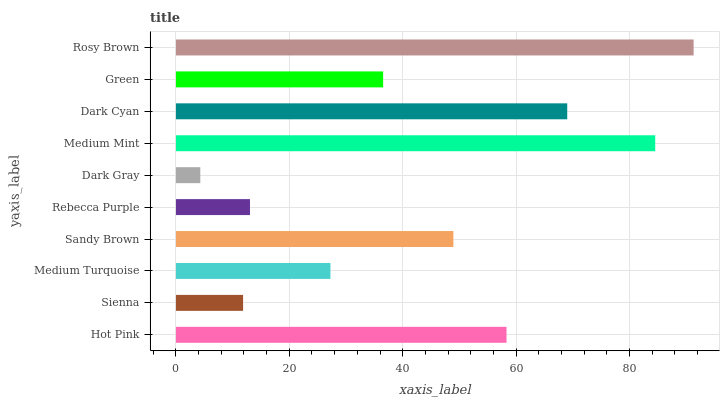Is Dark Gray the minimum?
Answer yes or no. Yes. Is Rosy Brown the maximum?
Answer yes or no. Yes. Is Sienna the minimum?
Answer yes or no. No. Is Sienna the maximum?
Answer yes or no. No. Is Hot Pink greater than Sienna?
Answer yes or no. Yes. Is Sienna less than Hot Pink?
Answer yes or no. Yes. Is Sienna greater than Hot Pink?
Answer yes or no. No. Is Hot Pink less than Sienna?
Answer yes or no. No. Is Sandy Brown the high median?
Answer yes or no. Yes. Is Green the low median?
Answer yes or no. Yes. Is Hot Pink the high median?
Answer yes or no. No. Is Medium Turquoise the low median?
Answer yes or no. No. 